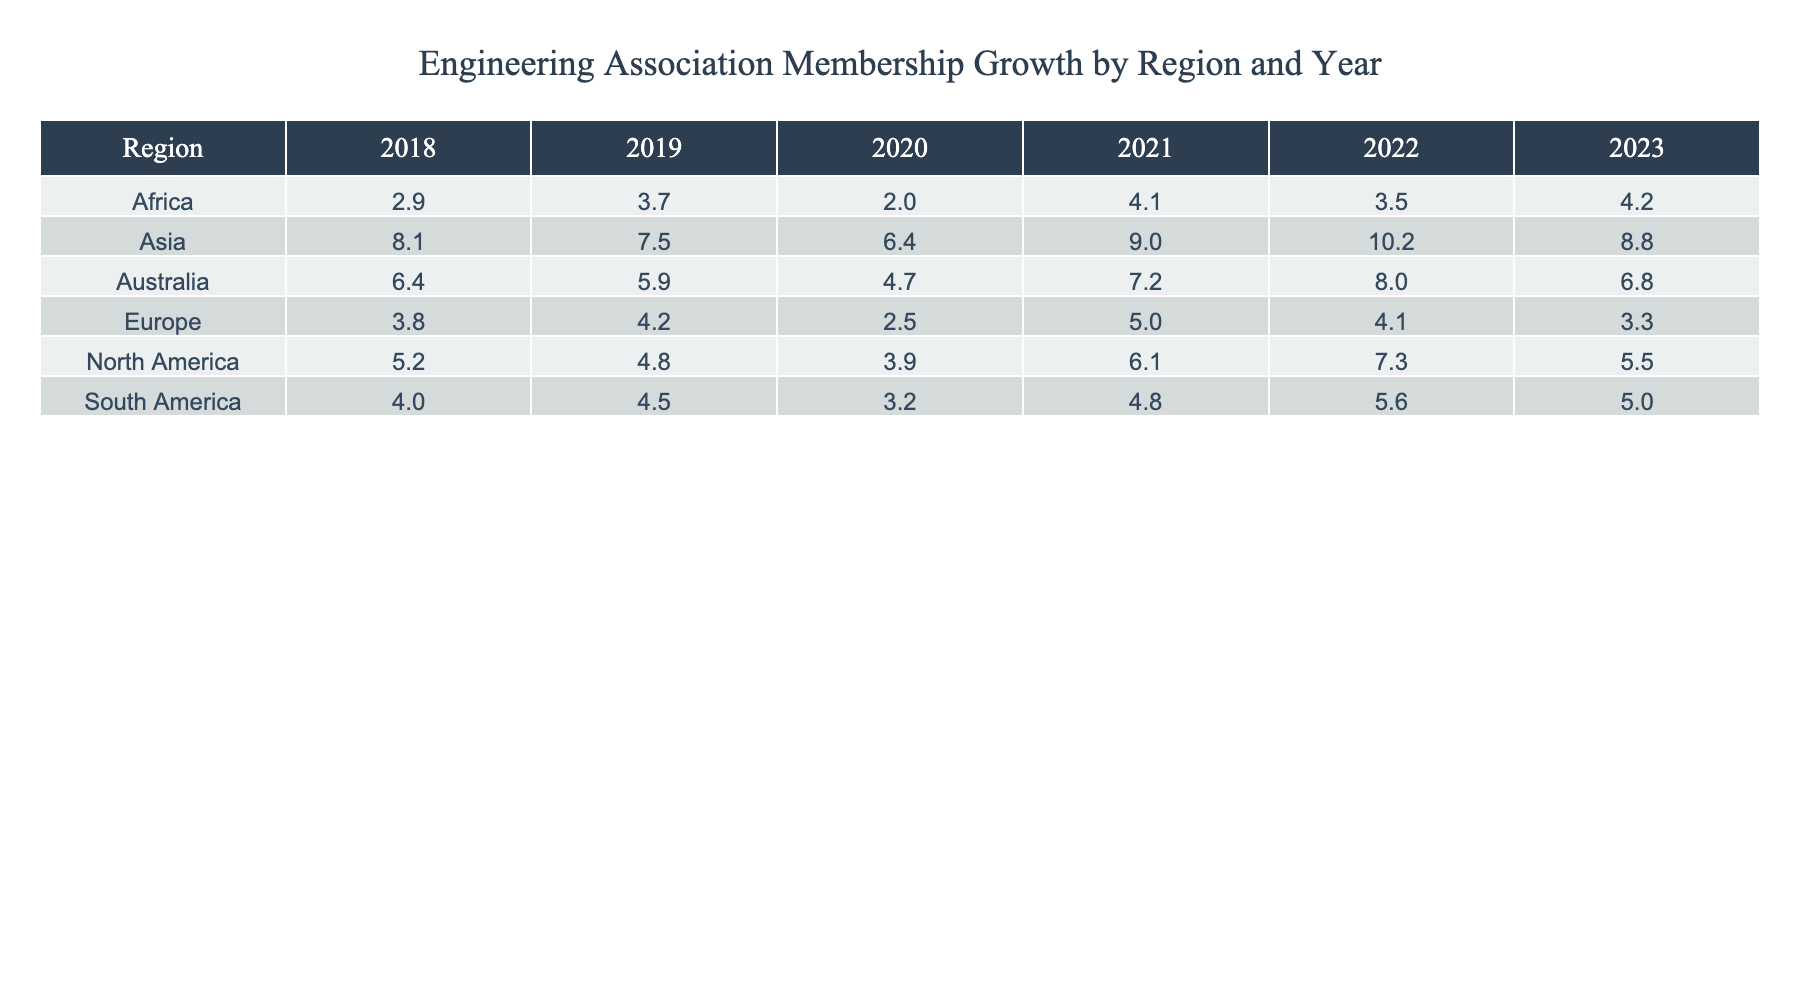What was the membership growth in North America in 2020? In the table, we can see that the value for North America under the year 2020 is 3.9%.
Answer: 3.9% Which region had the highest membership growth in 2022? By looking at the 2022 column, Asia has the highest value at 10.2%, while the other regions have lower growth percentages.
Answer: Asia What is the average membership growth for Europe from 2018 to 2023? To calculate the average for Europe, we add the membership growth percentages from 2018 to 2023: (3.8 + 4.2 + 2.5 + 5.0 + 4.1 + 3.3) = 23.0. Then we divide by 6: 23.0 / 6 = 3.83.
Answer: 3.83 Did South America experience a decline in membership growth from 2019 to 2020? Comparing the values in the table, South America had a membership growth of 4.5% in 2019 and 3.2% in 2020, showing a decline.
Answer: Yes What was the overall trend in membership growth for Asia from 2018 to 2023? Evaluating the values for Asia over the years: 8.1%, 7.5%, 6.4%, 9.0%, 10.2%, 8.8%, we see varied growth, with an increase in 2021 and 2022 but a slight decrease in 2019 and 2023, indicating fluctuation rather than a simple upward or downward trend.
Answer: Fluctuation Which region had the lowest membership growth in 2021? Checking the table for the year 2021, Africa has the lowest growth at 4.1%, compared to higher values in other regions.
Answer: Africa Calculate the total membership growth for Australia over the six years. Adding the values for Australia: (6.4 + 5.9 + 4.7 + 7.2 + 8.0 + 6.8) gives a total of 39.0%.
Answer: 39.0% Was there any year where Europe's membership growth percentage dropped below 3%? A review of the numbers shows Europe had a minimum growth of 2.5% in 2020, confirming that the percentage did fall below 3%.
Answer: Yes In which year did North America see the highest membership growth, and what was the percentage? In the provided data, North America shows the highest growth in 2022, with a membership growth of 7.3%.
Answer: 2022, 7.3% What was the percentage difference in membership growth for Africa between 2018 and 2023? For Africa, the percentage in 2018 is 2.9% and in 2023 is 4.2%. The difference is calculated as 4.2% - 2.9% = 1.3%.
Answer: 1.3% 